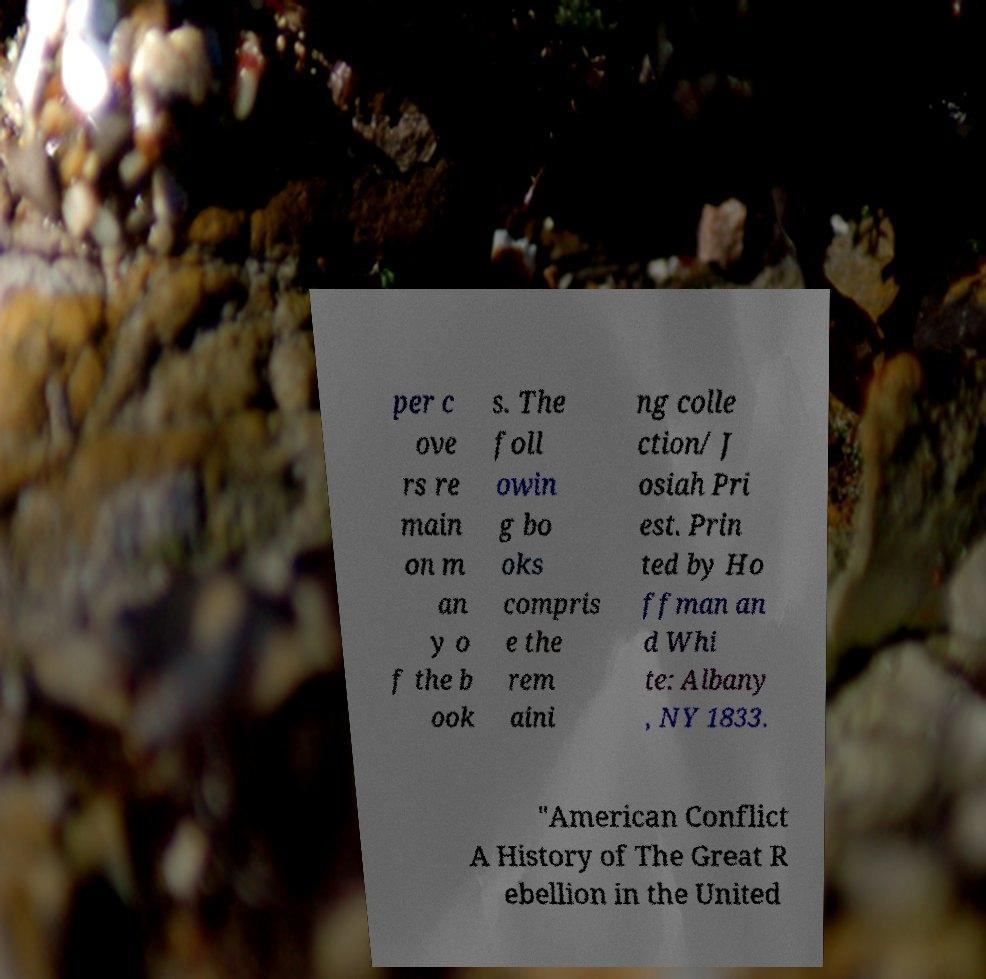Please read and relay the text visible in this image. What does it say? per c ove rs re main on m an y o f the b ook s. The foll owin g bo oks compris e the rem aini ng colle ction/ J osiah Pri est. Prin ted by Ho ffman an d Whi te: Albany , NY 1833. "American Conflict A History of The Great R ebellion in the United 